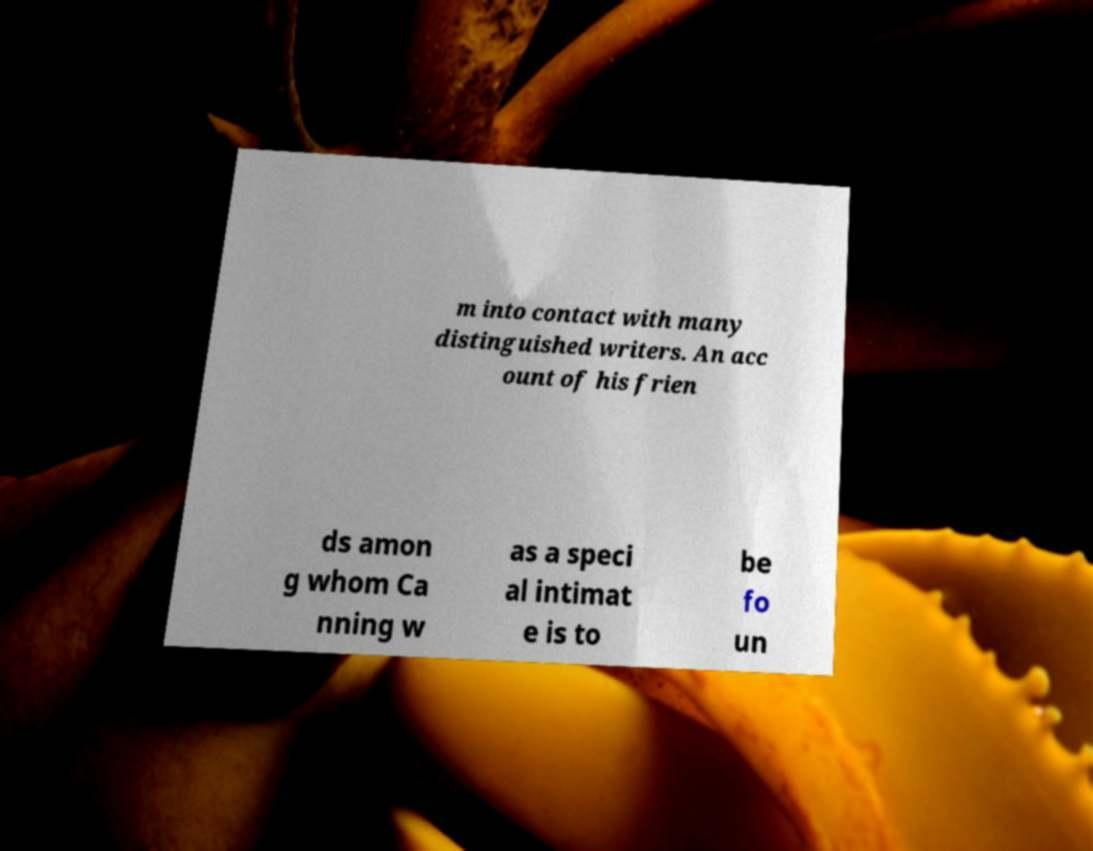Please read and relay the text visible in this image. What does it say? m into contact with many distinguished writers. An acc ount of his frien ds amon g whom Ca nning w as a speci al intimat e is to be fo un 